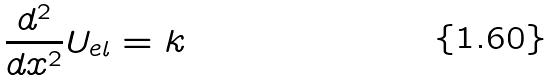<formula> <loc_0><loc_0><loc_500><loc_500>\frac { d ^ { 2 } } { d x ^ { 2 } } U _ { e l } = k</formula> 